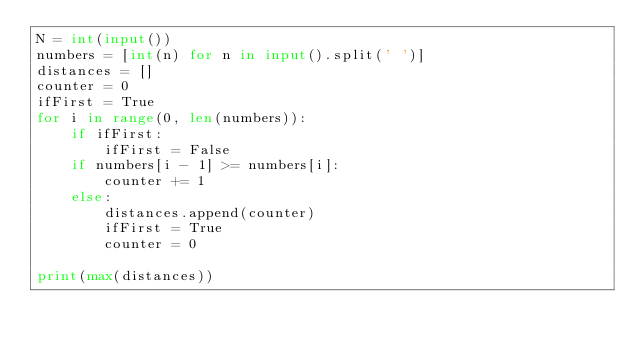Convert code to text. <code><loc_0><loc_0><loc_500><loc_500><_Python_>N = int(input())
numbers = [int(n) for n in input().split(' ')]
distances = []
counter = 0
ifFirst = True
for i in range(0, len(numbers)):
    if ifFirst:
        ifFirst = False
    if numbers[i - 1] >= numbers[i]:
        counter += 1
    else:
        distances.append(counter)
        ifFirst = True
        counter = 0

print(max(distances))</code> 